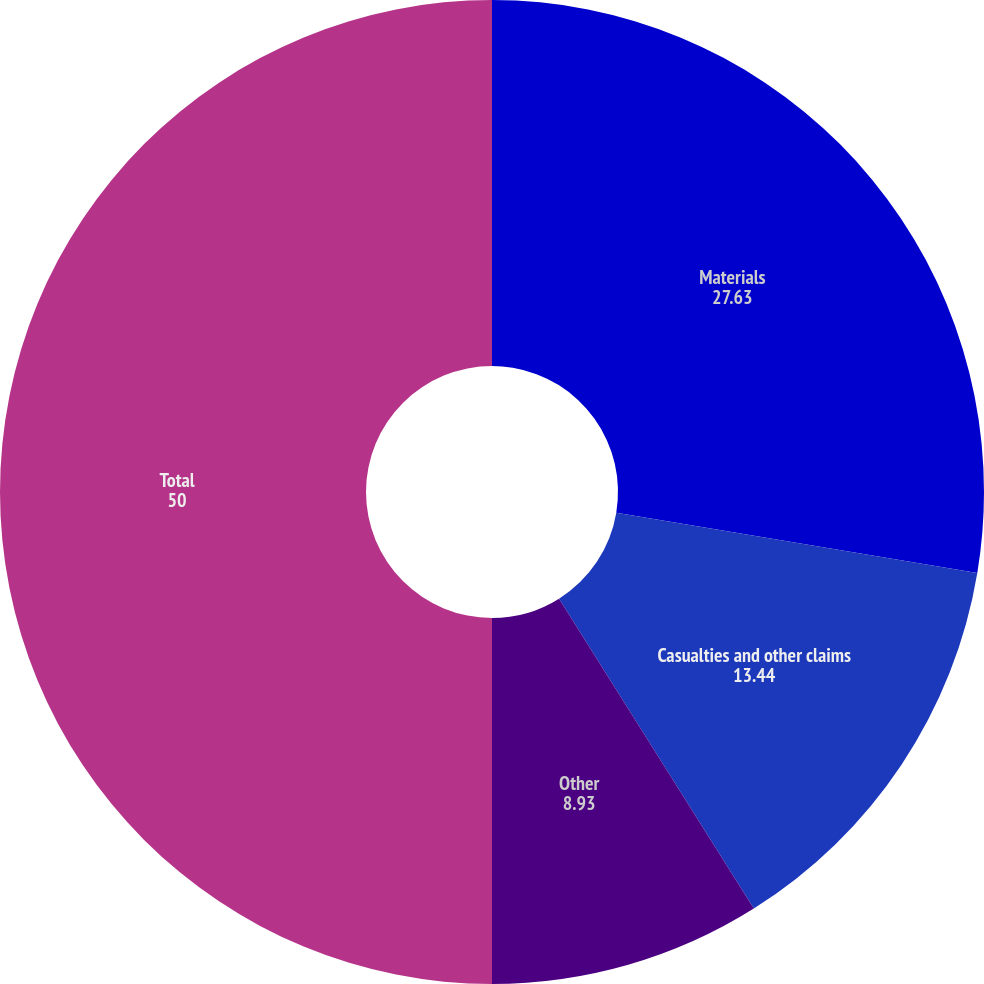Convert chart to OTSL. <chart><loc_0><loc_0><loc_500><loc_500><pie_chart><fcel>Materials<fcel>Casualties and other claims<fcel>Other<fcel>Total<nl><fcel>27.63%<fcel>13.44%<fcel>8.93%<fcel>50.0%<nl></chart> 